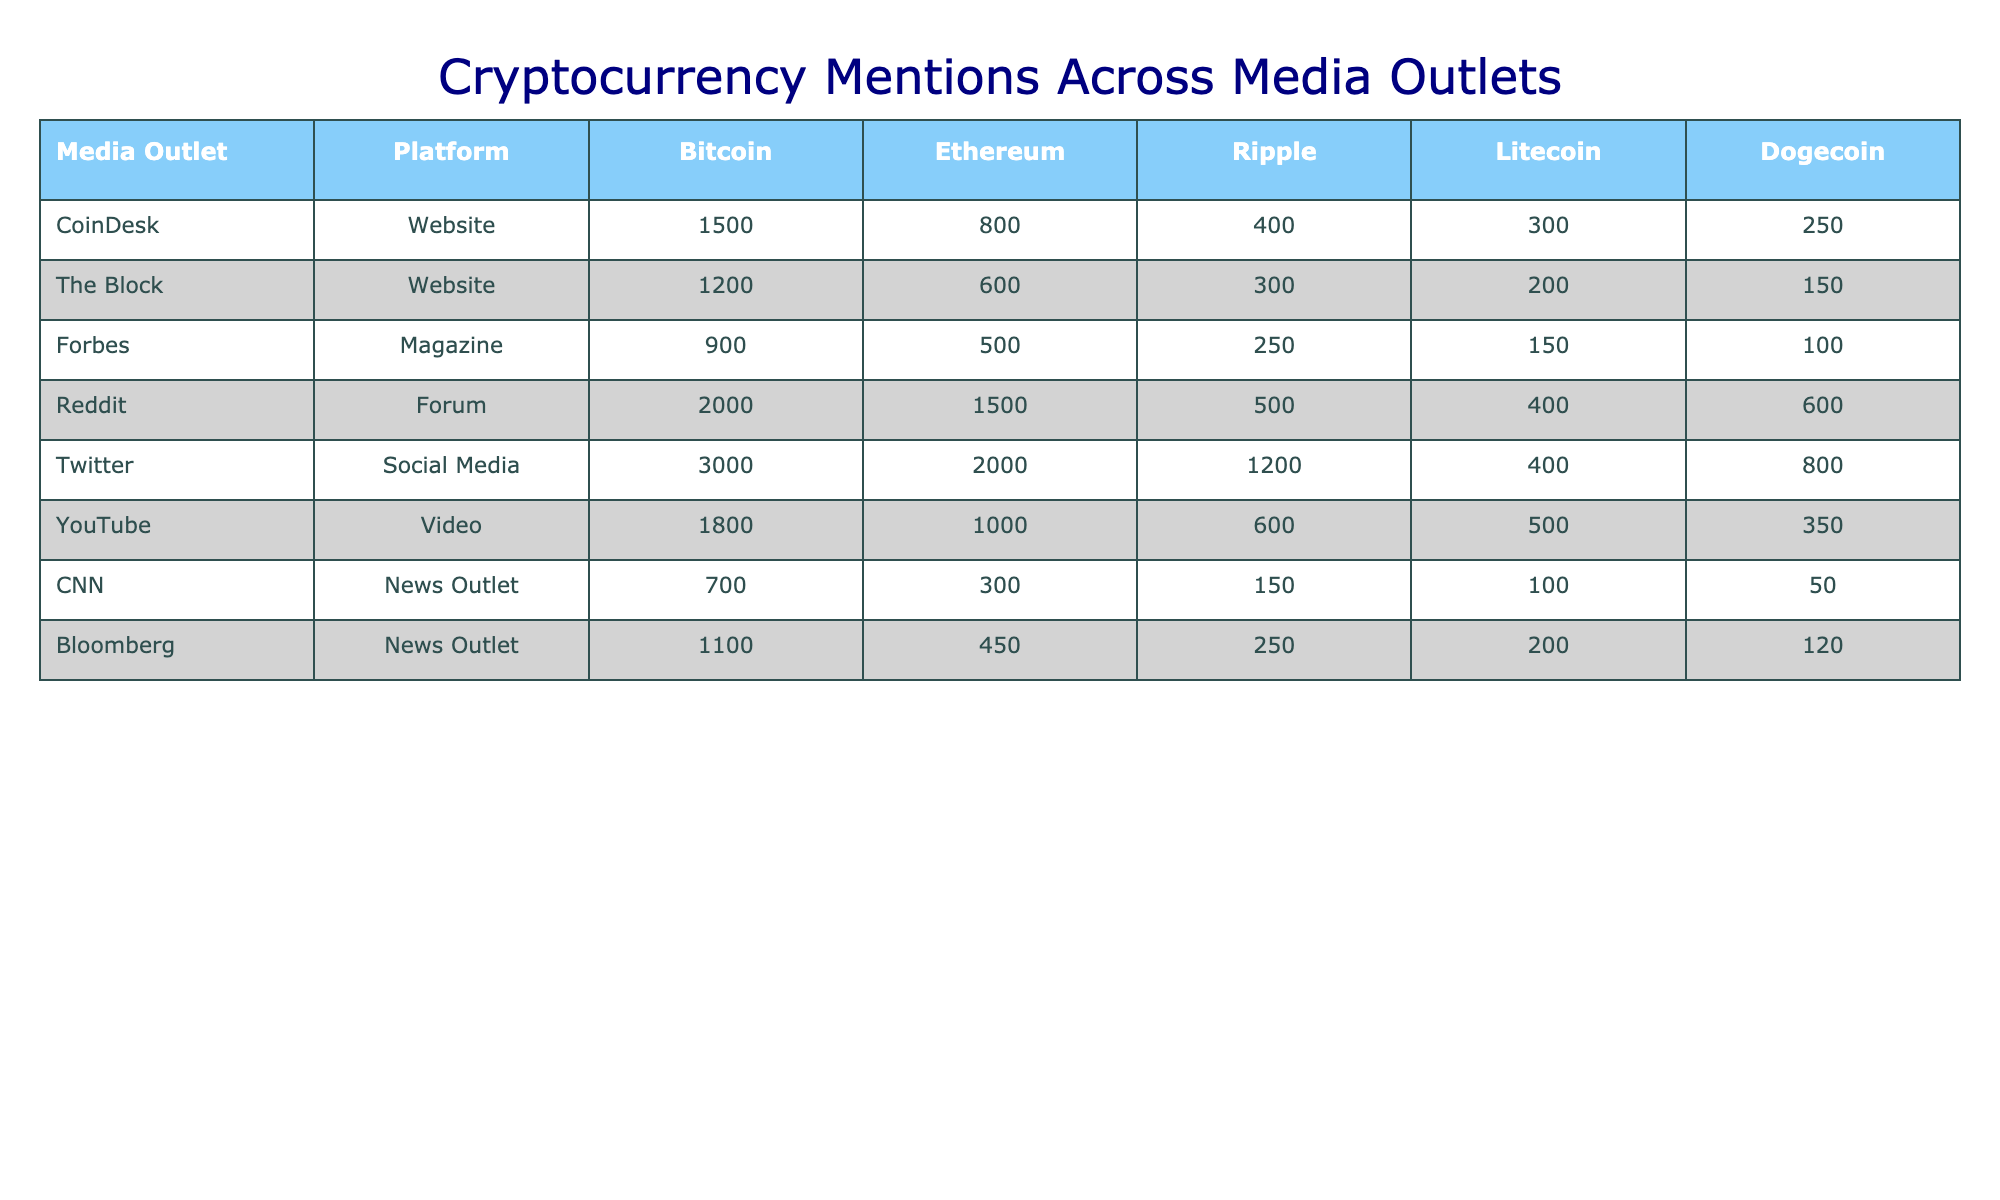What media outlet mentions Bitcoin the most? By checking the table, we see that Twitter mentions Bitcoin 3000 times, which is higher than all other outlets listed.
Answer: Twitter What is the total number of mentions for Ethereum across all media outlets? Summing the mentions for Ethereum: 800 + 600 + 500 + 1500 + 2000 + 1000 + 300 + 450 = 6550.
Answer: 6550 Is Reddit the platform with the highest mentions for Dogecoin? Looking at the table, Reddit has 600 mentions for Dogecoin, which is more than any other outlet.
Answer: Yes What is the average number of mentions for Litecoin across the outlets? The total mentions for Litecoin are 300 + 200 + 150 + 400 + 400 + 500 + 100 + 200 = 2250. Dividing this by 8 gives an average of 281.25.
Answer: 281.25 How many more mentions does Twitter have for Bitcoin than Bloomberg? Bitcoin mentions on Twitter are 3000 and on Bloomberg it is 1100. Subtracting the two gives 3000 - 1100 = 1900.
Answer: 1900 Which media outlet has the lowest total mention counts across all cryptocurrencies? By summing total mentions for each outlet: CoinDesk (3050), The Block (2850), Forbes (1900), Reddit (4100), Twitter (8000), YouTube (3250), CNN (1300), Bloomberg (2170). CNN has the lowest total mentions with 1300.
Answer: CNN What is the percentage share of mentions for Ripple on Twitter compared to its total mentions across all outlets? Ripple mentions on Twitter are 1200. The total mentions across all outlets for Ripple are 2950 (400 + 300 + 250 + 500 + 1200 + 600 + 150 + 250). The percentage is (1200 / 2950) * 100 = approximately 40.68%.
Answer: Approximately 40.68% Is it true that CoinDesk mentions Dogecoin more than Forbes? CoinDesk has 250 mentions for Dogecoin while Forbes only has 100. CoinDesk mentions Dogecoin more than Forbes.
Answer: Yes What is the difference in total mentions of Bitcoin and Ethereum across all media outlets? Total Bitcoin mentions are 3050, and total Ethereum mentions are 6550. The difference is 6550 - 3050 = 3500.
Answer: 3500 